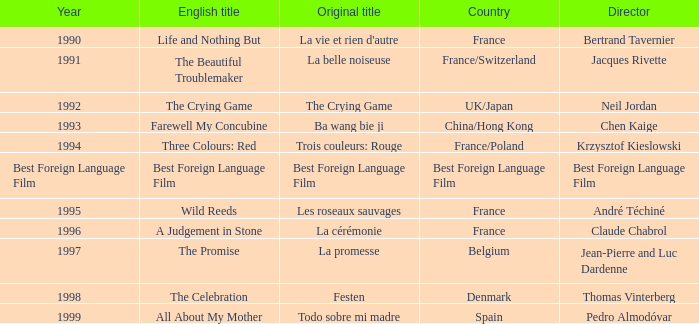What is the initial title of the english title a judgement in stone? La cérémonie. 